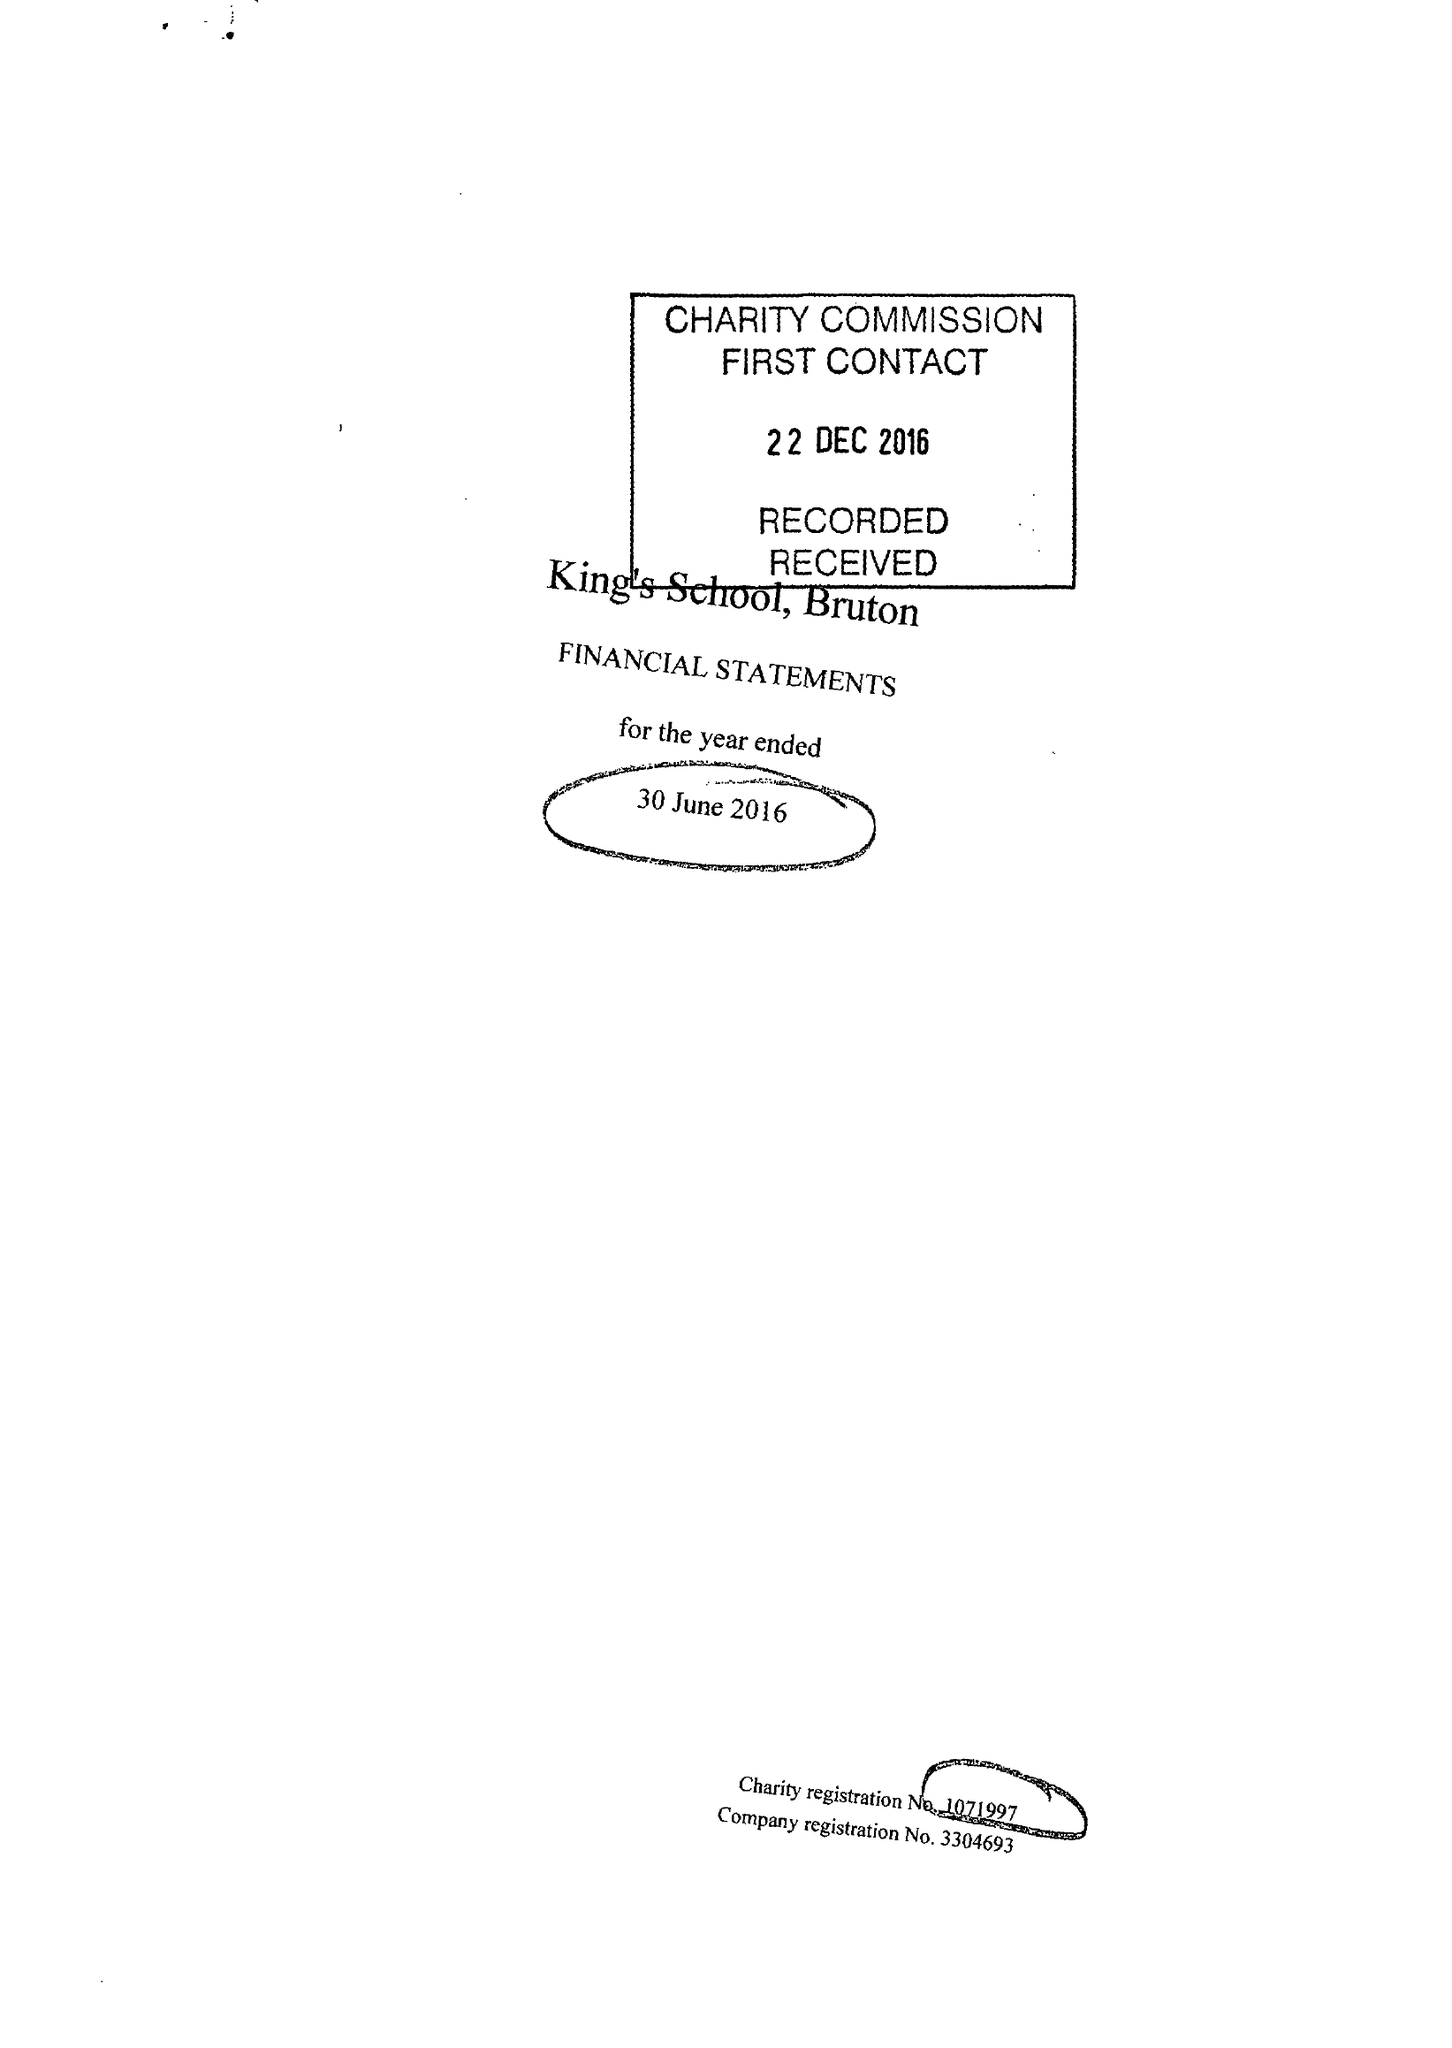What is the value for the income_annually_in_british_pounds?
Answer the question using a single word or phrase. 13886592.00 